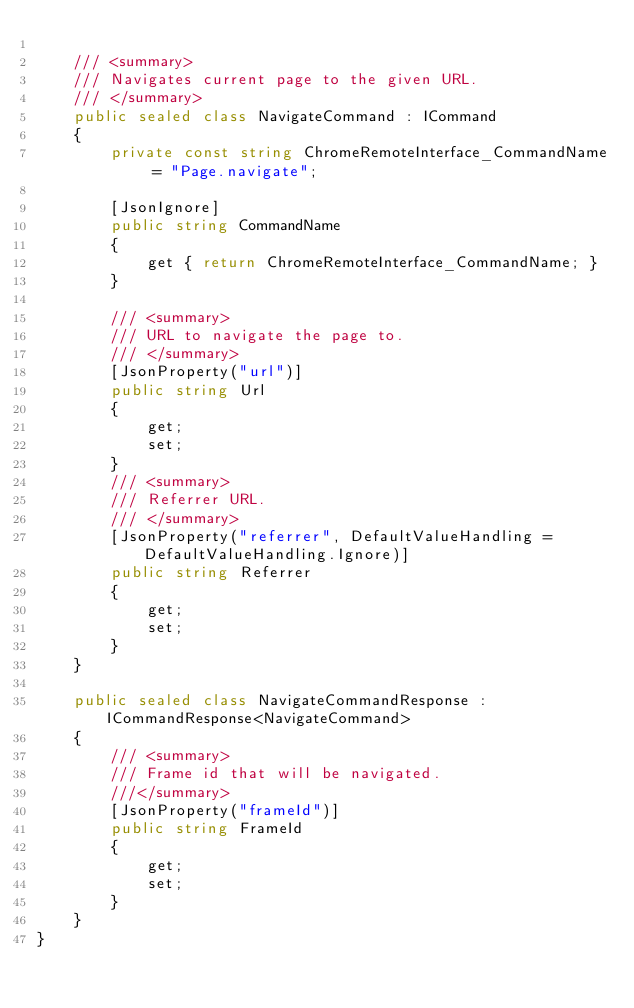<code> <loc_0><loc_0><loc_500><loc_500><_C#_>
    /// <summary>
    /// Navigates current page to the given URL.
    /// </summary>
    public sealed class NavigateCommand : ICommand
    {
        private const string ChromeRemoteInterface_CommandName = "Page.navigate";
        
        [JsonIgnore]
        public string CommandName
        {
            get { return ChromeRemoteInterface_CommandName; }
        }

        /// <summary>
        /// URL to navigate the page to.
        /// </summary>
        [JsonProperty("url")]
        public string Url
        {
            get;
            set;
        }
        /// <summary>
        /// Referrer URL.
        /// </summary>
        [JsonProperty("referrer", DefaultValueHandling = DefaultValueHandling.Ignore)]
        public string Referrer
        {
            get;
            set;
        }
    }

    public sealed class NavigateCommandResponse : ICommandResponse<NavigateCommand>
    {
        /// <summary>
        /// Frame id that will be navigated.
        ///</summary>
        [JsonProperty("frameId")]
        public string FrameId
        {
            get;
            set;
        }
    }
}</code> 